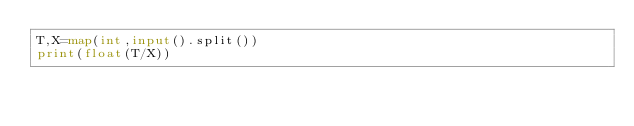<code> <loc_0><loc_0><loc_500><loc_500><_Python_>T,X=map(int,input().split())
print(float(T/X))</code> 